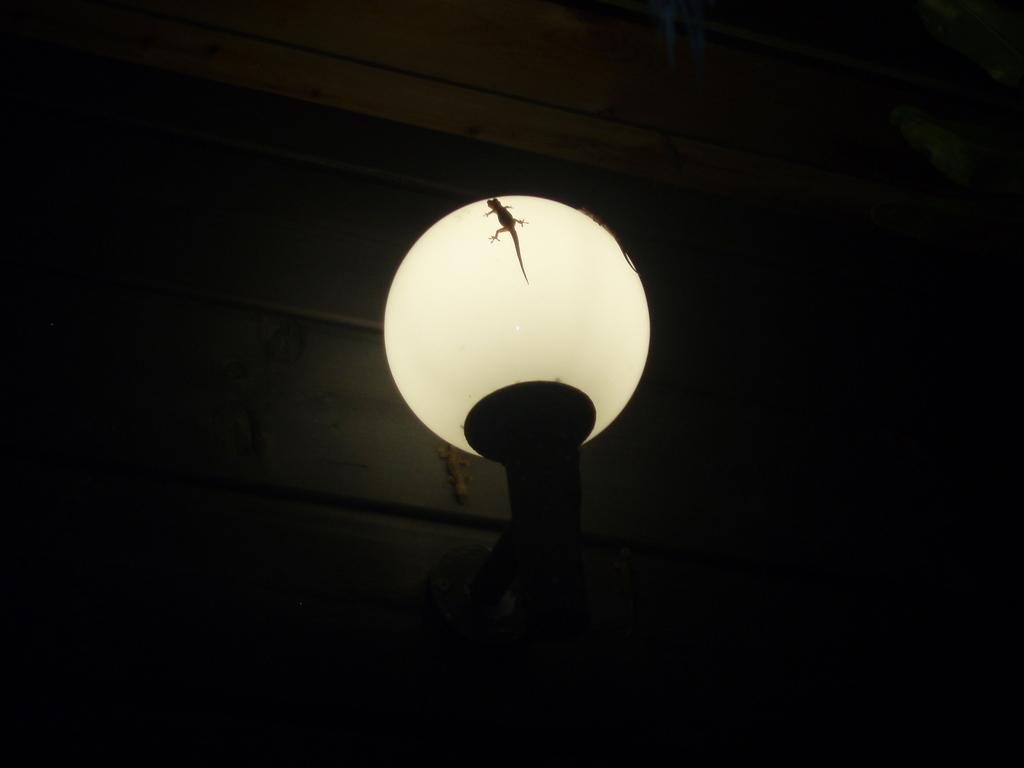What animals are on the lamp in the image? There are lizards on the lamp in the image. Where is the lamp located? The lamp is placed on a stand. Can you describe the background of the image? There is a lizard on the wall in the background of the image. What type of spot is the cook using to prepare the rat in the image? There is no spot, cook, or rat present in the image; it features lizards on a lamp and a lizard on the wall in the background. 